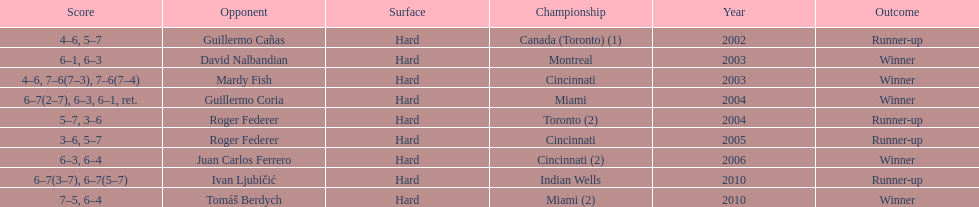What was the greatest number of back-to-back wins recorded? 3. 